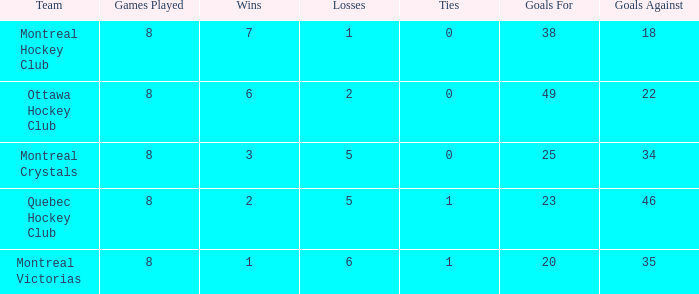What is the sum of the losses when the goals against is less than 34 and the games played is less than 8? None. 